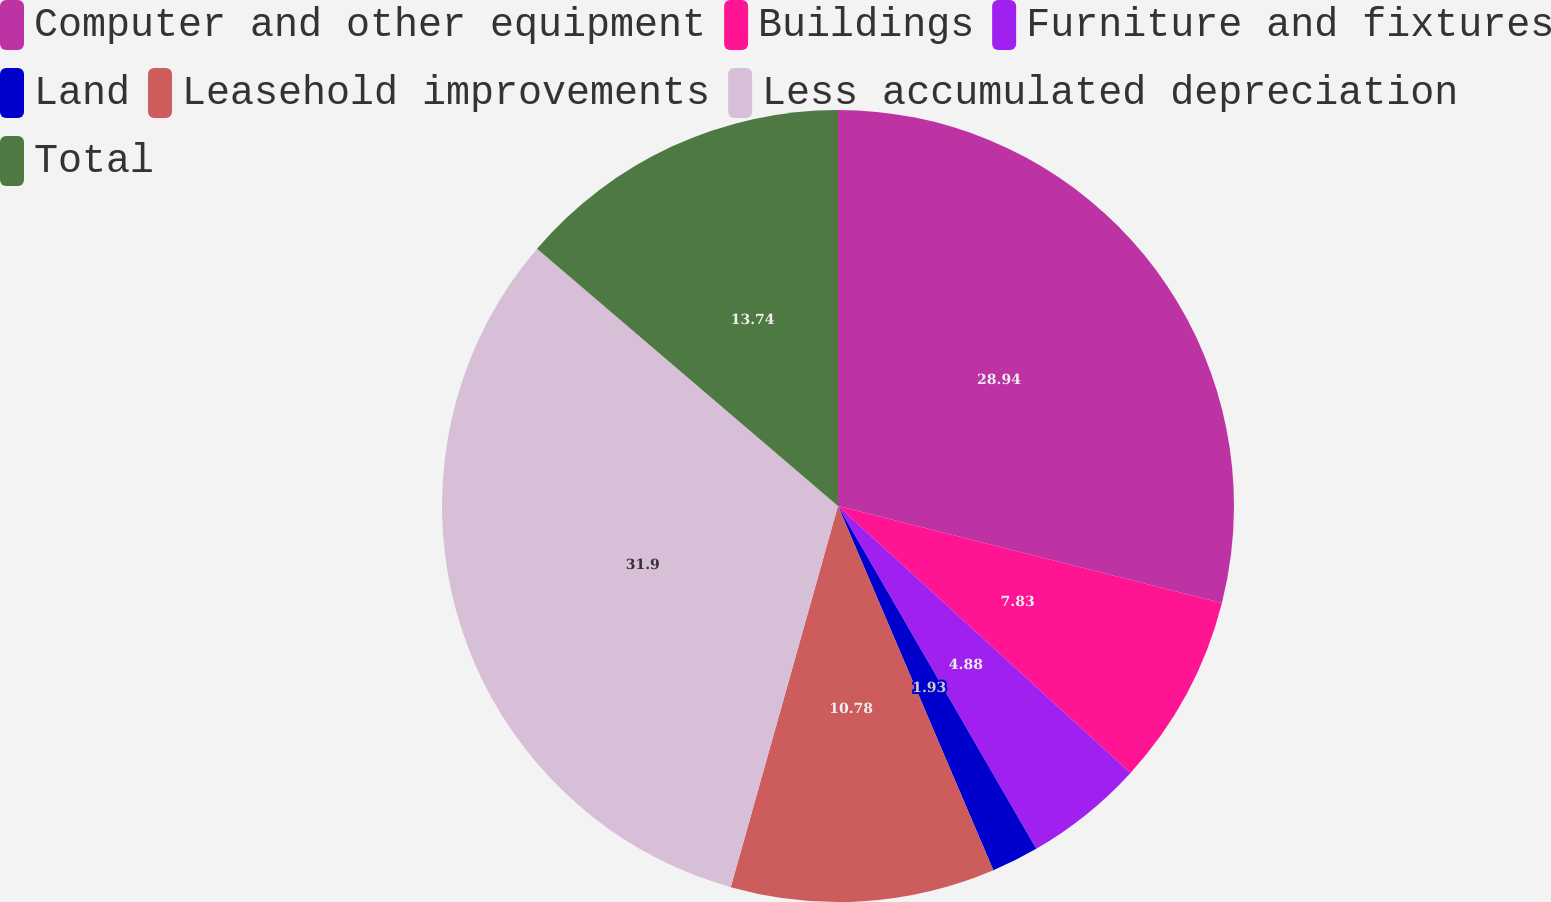Convert chart. <chart><loc_0><loc_0><loc_500><loc_500><pie_chart><fcel>Computer and other equipment<fcel>Buildings<fcel>Furniture and fixtures<fcel>Land<fcel>Leasehold improvements<fcel>Less accumulated depreciation<fcel>Total<nl><fcel>28.94%<fcel>7.83%<fcel>4.88%<fcel>1.93%<fcel>10.78%<fcel>31.89%<fcel>13.74%<nl></chart> 